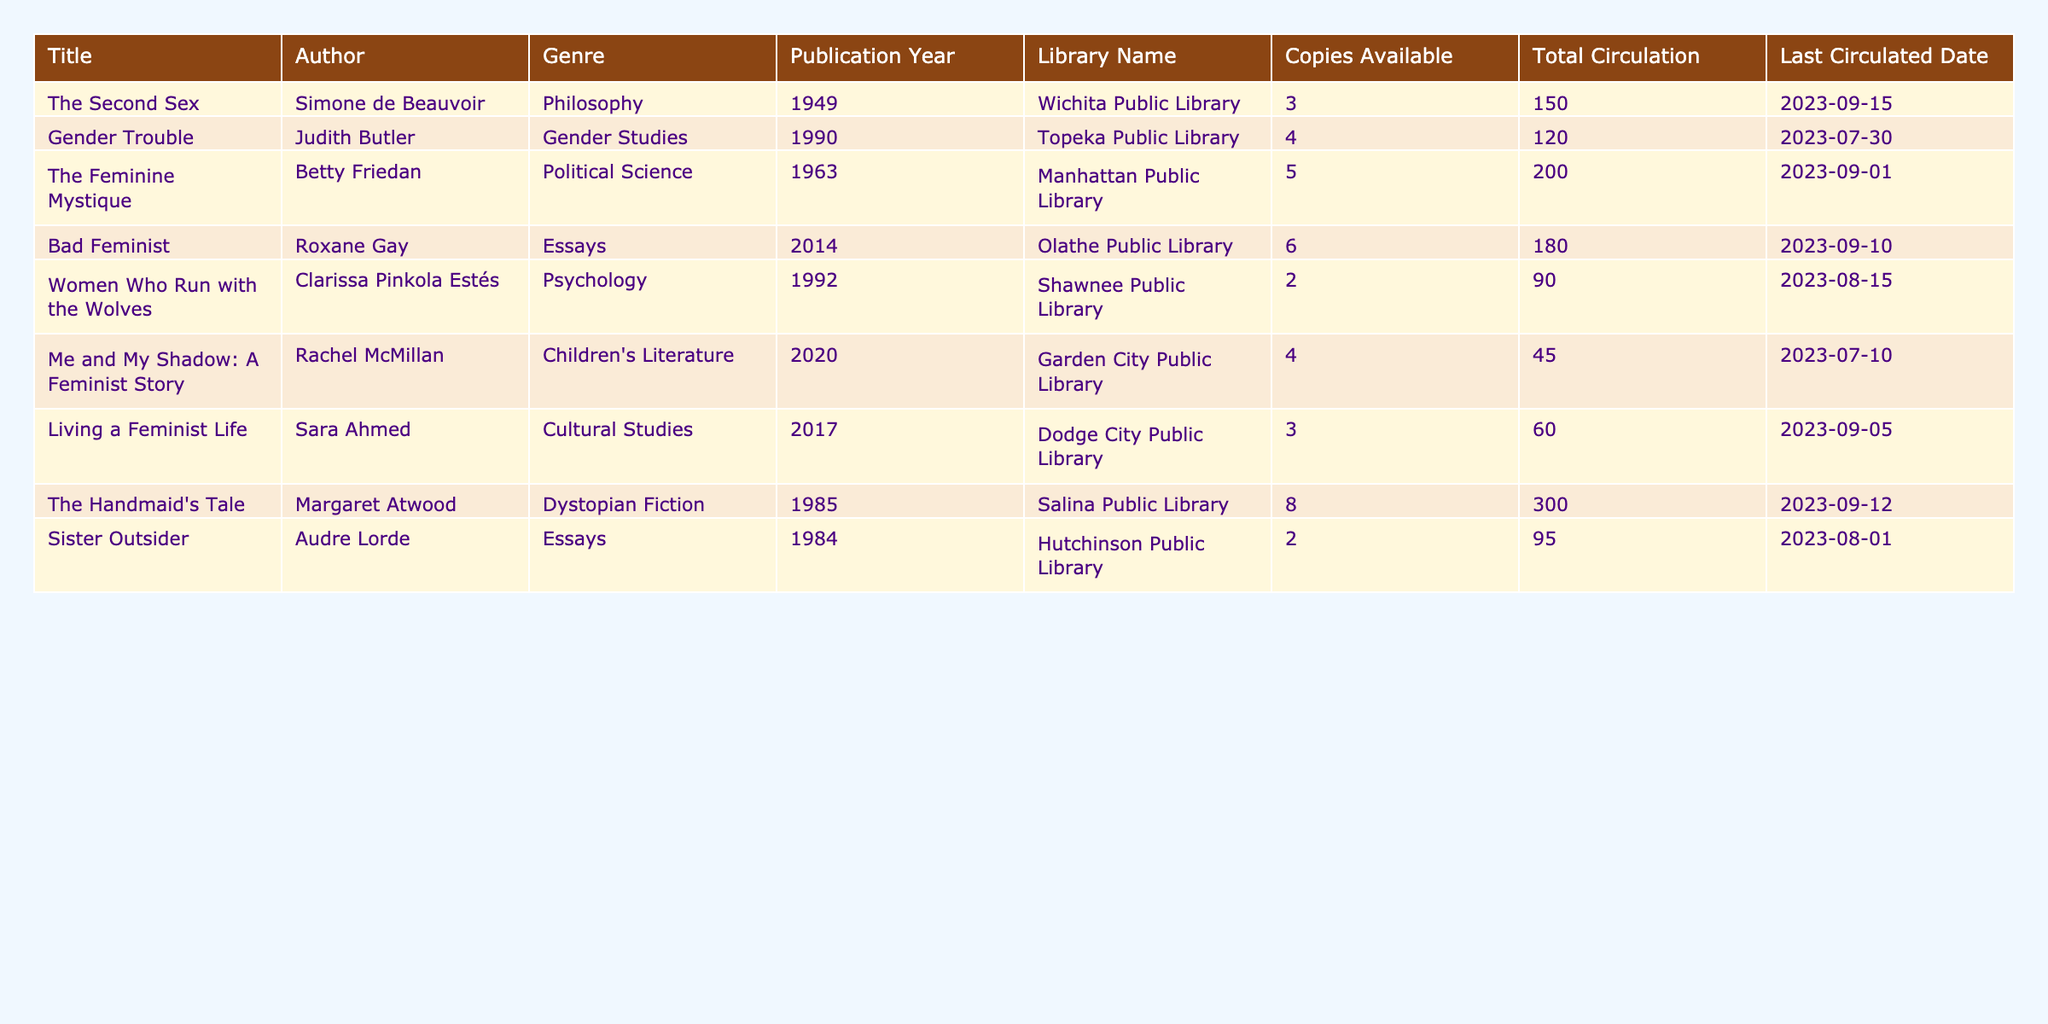What is the total number of copies available for "The Handmaid's Tale"? Referring to the row for "The Handmaid's Tale", the column "Copies Available" shows a value of 8.
Answer: 8 What is the total circulation of all titles combined? To find the total circulation, add the values in the "Total Circulation" column: 150 + 120 + 200 + 180 + 90 + 45 + 60 + 300 + 95 = 1240.
Answer: 1240 Is "Gender Trouble" the most circulated book? In the "Total Circulation" column, "Gender Trouble" has a value of 120, while "The Feminine Mystique" has 200 and "The Handmaid's Tale" has 300. Therefore, "Gender Trouble" is not the most circulated book.
Answer: No How many copies available does "Bad Feminist" have compared to "Women Who Run with the Wolves"? "Bad Feminist" has 6 copies available, while "Women Who Run with the Wolves" has 2. The difference is 6 - 2 = 4.
Answer: 4 Which author has the highest total circulation for their books? Summing total circulation by author, "Margaret Atwood" (300), "Betty Friedan" (200), "Roxane Gay" (180), "Simone de Beauvoir" (150), and so on. "Margaret Atwood" has the highest circulation of 300.
Answer: Margaret Atwood What is the average number of copies available across all titles? The total number of copies available is 3 + 4 + 5 + 6 + 2 + 4 + 3 + 8 + 2 = 37. There are 9 titles, so the average is 37 / 9 = approximately 4.11.
Answer: 4.11 Is there a book from the 21st century available in the "Dystopian Fiction" genre? Checking the "Genre" column for "Dystopian Fiction", we find "The Handmaid's Tale" from 1985, which is not from the 21st century. Therefore, there is no 21st-century Dystopian Fiction book.
Answer: No What is the difference in total circulation between "The Feminine Mystique" and "Sister Outsider"? "The Feminine Mystique" has a total circulation of 200, while "Sister Outsider" has 95. The difference is 200 - 95 = 105.
Answer: 105 Which title has the last circulated date nearest to today? By examining the "Last Circulated Date" column, "The Handmaid's Tale" has the latest date of 2023-09-12.
Answer: The Handmaid's Tale How many libraries have at least 5 copies available? "The Feminine Mystique" (5), "Bad Feminist" (6), and "The Handmaid's Tale" (8) are the only titles with 5 or more copies, which totals 3 libraries.
Answer: 3 